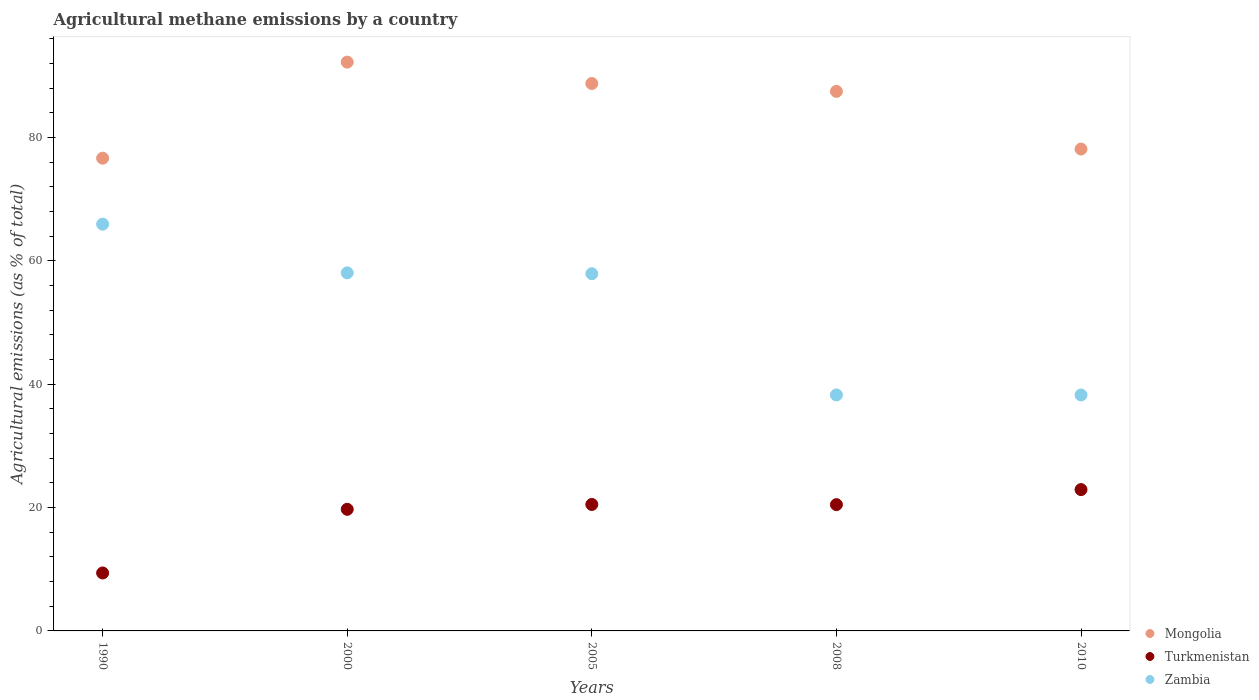Is the number of dotlines equal to the number of legend labels?
Your answer should be very brief. Yes. What is the amount of agricultural methane emitted in Mongolia in 2010?
Your answer should be very brief. 78.14. Across all years, what is the maximum amount of agricultural methane emitted in Zambia?
Your response must be concise. 65.96. Across all years, what is the minimum amount of agricultural methane emitted in Mongolia?
Provide a succinct answer. 76.66. In which year was the amount of agricultural methane emitted in Turkmenistan maximum?
Provide a succinct answer. 2010. What is the total amount of agricultural methane emitted in Turkmenistan in the graph?
Ensure brevity in your answer.  93.02. What is the difference between the amount of agricultural methane emitted in Zambia in 1990 and that in 2008?
Give a very brief answer. 27.69. What is the difference between the amount of agricultural methane emitted in Mongolia in 2000 and the amount of agricultural methane emitted in Zambia in 2010?
Offer a terse response. 53.98. What is the average amount of agricultural methane emitted in Mongolia per year?
Keep it short and to the point. 84.66. In the year 2008, what is the difference between the amount of agricultural methane emitted in Turkmenistan and amount of agricultural methane emitted in Mongolia?
Keep it short and to the point. -67.01. What is the ratio of the amount of agricultural methane emitted in Turkmenistan in 2000 to that in 2010?
Provide a short and direct response. 0.86. Is the amount of agricultural methane emitted in Mongolia in 2005 less than that in 2010?
Ensure brevity in your answer.  No. What is the difference between the highest and the second highest amount of agricultural methane emitted in Zambia?
Keep it short and to the point. 7.9. What is the difference between the highest and the lowest amount of agricultural methane emitted in Mongolia?
Keep it short and to the point. 15.58. In how many years, is the amount of agricultural methane emitted in Turkmenistan greater than the average amount of agricultural methane emitted in Turkmenistan taken over all years?
Your response must be concise. 4. Is the sum of the amount of agricultural methane emitted in Mongolia in 1990 and 2010 greater than the maximum amount of agricultural methane emitted in Zambia across all years?
Make the answer very short. Yes. Is the amount of agricultural methane emitted in Turkmenistan strictly greater than the amount of agricultural methane emitted in Mongolia over the years?
Provide a succinct answer. No. What is the difference between two consecutive major ticks on the Y-axis?
Ensure brevity in your answer.  20. Are the values on the major ticks of Y-axis written in scientific E-notation?
Your answer should be compact. No. Where does the legend appear in the graph?
Your response must be concise. Bottom right. What is the title of the graph?
Ensure brevity in your answer.  Agricultural methane emissions by a country. Does "Peru" appear as one of the legend labels in the graph?
Make the answer very short. No. What is the label or title of the X-axis?
Make the answer very short. Years. What is the label or title of the Y-axis?
Your response must be concise. Agricultural emissions (as % of total). What is the Agricultural emissions (as % of total) in Mongolia in 1990?
Keep it short and to the point. 76.66. What is the Agricultural emissions (as % of total) of Turkmenistan in 1990?
Ensure brevity in your answer.  9.4. What is the Agricultural emissions (as % of total) of Zambia in 1990?
Provide a short and direct response. 65.96. What is the Agricultural emissions (as % of total) of Mongolia in 2000?
Offer a very short reply. 92.24. What is the Agricultural emissions (as % of total) in Turkmenistan in 2000?
Your answer should be very brief. 19.72. What is the Agricultural emissions (as % of total) in Zambia in 2000?
Offer a very short reply. 58.06. What is the Agricultural emissions (as % of total) of Mongolia in 2005?
Ensure brevity in your answer.  88.77. What is the Agricultural emissions (as % of total) of Turkmenistan in 2005?
Make the answer very short. 20.51. What is the Agricultural emissions (as % of total) in Zambia in 2005?
Your answer should be compact. 57.92. What is the Agricultural emissions (as % of total) in Mongolia in 2008?
Give a very brief answer. 87.49. What is the Agricultural emissions (as % of total) in Turkmenistan in 2008?
Keep it short and to the point. 20.48. What is the Agricultural emissions (as % of total) of Zambia in 2008?
Your answer should be compact. 38.27. What is the Agricultural emissions (as % of total) in Mongolia in 2010?
Offer a very short reply. 78.14. What is the Agricultural emissions (as % of total) in Turkmenistan in 2010?
Your answer should be very brief. 22.92. What is the Agricultural emissions (as % of total) of Zambia in 2010?
Your response must be concise. 38.26. Across all years, what is the maximum Agricultural emissions (as % of total) in Mongolia?
Give a very brief answer. 92.24. Across all years, what is the maximum Agricultural emissions (as % of total) of Turkmenistan?
Your answer should be very brief. 22.92. Across all years, what is the maximum Agricultural emissions (as % of total) in Zambia?
Your answer should be very brief. 65.96. Across all years, what is the minimum Agricultural emissions (as % of total) of Mongolia?
Offer a terse response. 76.66. Across all years, what is the minimum Agricultural emissions (as % of total) in Turkmenistan?
Provide a short and direct response. 9.4. Across all years, what is the minimum Agricultural emissions (as % of total) of Zambia?
Give a very brief answer. 38.26. What is the total Agricultural emissions (as % of total) of Mongolia in the graph?
Offer a terse response. 423.3. What is the total Agricultural emissions (as % of total) in Turkmenistan in the graph?
Your answer should be compact. 93.02. What is the total Agricultural emissions (as % of total) of Zambia in the graph?
Provide a succinct answer. 258.47. What is the difference between the Agricultural emissions (as % of total) in Mongolia in 1990 and that in 2000?
Your answer should be very brief. -15.58. What is the difference between the Agricultural emissions (as % of total) in Turkmenistan in 1990 and that in 2000?
Make the answer very short. -10.32. What is the difference between the Agricultural emissions (as % of total) of Zambia in 1990 and that in 2000?
Your answer should be compact. 7.9. What is the difference between the Agricultural emissions (as % of total) of Mongolia in 1990 and that in 2005?
Keep it short and to the point. -12.11. What is the difference between the Agricultural emissions (as % of total) in Turkmenistan in 1990 and that in 2005?
Your answer should be very brief. -11.11. What is the difference between the Agricultural emissions (as % of total) of Zambia in 1990 and that in 2005?
Your response must be concise. 8.04. What is the difference between the Agricultural emissions (as % of total) in Mongolia in 1990 and that in 2008?
Your response must be concise. -10.83. What is the difference between the Agricultural emissions (as % of total) of Turkmenistan in 1990 and that in 2008?
Your response must be concise. -11.08. What is the difference between the Agricultural emissions (as % of total) of Zambia in 1990 and that in 2008?
Provide a short and direct response. 27.69. What is the difference between the Agricultural emissions (as % of total) in Mongolia in 1990 and that in 2010?
Your response must be concise. -1.48. What is the difference between the Agricultural emissions (as % of total) of Turkmenistan in 1990 and that in 2010?
Offer a very short reply. -13.52. What is the difference between the Agricultural emissions (as % of total) of Zambia in 1990 and that in 2010?
Provide a succinct answer. 27.7. What is the difference between the Agricultural emissions (as % of total) in Mongolia in 2000 and that in 2005?
Provide a short and direct response. 3.47. What is the difference between the Agricultural emissions (as % of total) in Turkmenistan in 2000 and that in 2005?
Make the answer very short. -0.79. What is the difference between the Agricultural emissions (as % of total) in Zambia in 2000 and that in 2005?
Offer a very short reply. 0.14. What is the difference between the Agricultural emissions (as % of total) in Mongolia in 2000 and that in 2008?
Ensure brevity in your answer.  4.74. What is the difference between the Agricultural emissions (as % of total) of Turkmenistan in 2000 and that in 2008?
Keep it short and to the point. -0.76. What is the difference between the Agricultural emissions (as % of total) in Zambia in 2000 and that in 2008?
Offer a very short reply. 19.79. What is the difference between the Agricultural emissions (as % of total) in Mongolia in 2000 and that in 2010?
Your answer should be very brief. 14.1. What is the difference between the Agricultural emissions (as % of total) in Turkmenistan in 2000 and that in 2010?
Keep it short and to the point. -3.2. What is the difference between the Agricultural emissions (as % of total) in Zambia in 2000 and that in 2010?
Your answer should be very brief. 19.8. What is the difference between the Agricultural emissions (as % of total) in Mongolia in 2005 and that in 2008?
Offer a very short reply. 1.28. What is the difference between the Agricultural emissions (as % of total) in Turkmenistan in 2005 and that in 2008?
Offer a very short reply. 0.03. What is the difference between the Agricultural emissions (as % of total) in Zambia in 2005 and that in 2008?
Your answer should be compact. 19.65. What is the difference between the Agricultural emissions (as % of total) in Mongolia in 2005 and that in 2010?
Make the answer very short. 10.63. What is the difference between the Agricultural emissions (as % of total) of Turkmenistan in 2005 and that in 2010?
Give a very brief answer. -2.41. What is the difference between the Agricultural emissions (as % of total) of Zambia in 2005 and that in 2010?
Your answer should be compact. 19.66. What is the difference between the Agricultural emissions (as % of total) of Mongolia in 2008 and that in 2010?
Make the answer very short. 9.35. What is the difference between the Agricultural emissions (as % of total) of Turkmenistan in 2008 and that in 2010?
Your answer should be compact. -2.44. What is the difference between the Agricultural emissions (as % of total) of Zambia in 2008 and that in 2010?
Give a very brief answer. 0.01. What is the difference between the Agricultural emissions (as % of total) of Mongolia in 1990 and the Agricultural emissions (as % of total) of Turkmenistan in 2000?
Ensure brevity in your answer.  56.94. What is the difference between the Agricultural emissions (as % of total) of Mongolia in 1990 and the Agricultural emissions (as % of total) of Zambia in 2000?
Give a very brief answer. 18.6. What is the difference between the Agricultural emissions (as % of total) of Turkmenistan in 1990 and the Agricultural emissions (as % of total) of Zambia in 2000?
Your answer should be very brief. -48.66. What is the difference between the Agricultural emissions (as % of total) of Mongolia in 1990 and the Agricultural emissions (as % of total) of Turkmenistan in 2005?
Give a very brief answer. 56.15. What is the difference between the Agricultural emissions (as % of total) of Mongolia in 1990 and the Agricultural emissions (as % of total) of Zambia in 2005?
Provide a short and direct response. 18.74. What is the difference between the Agricultural emissions (as % of total) of Turkmenistan in 1990 and the Agricultural emissions (as % of total) of Zambia in 2005?
Your answer should be compact. -48.52. What is the difference between the Agricultural emissions (as % of total) in Mongolia in 1990 and the Agricultural emissions (as % of total) in Turkmenistan in 2008?
Ensure brevity in your answer.  56.18. What is the difference between the Agricultural emissions (as % of total) of Mongolia in 1990 and the Agricultural emissions (as % of total) of Zambia in 2008?
Give a very brief answer. 38.39. What is the difference between the Agricultural emissions (as % of total) in Turkmenistan in 1990 and the Agricultural emissions (as % of total) in Zambia in 2008?
Your answer should be compact. -28.87. What is the difference between the Agricultural emissions (as % of total) in Mongolia in 1990 and the Agricultural emissions (as % of total) in Turkmenistan in 2010?
Your answer should be compact. 53.74. What is the difference between the Agricultural emissions (as % of total) in Mongolia in 1990 and the Agricultural emissions (as % of total) in Zambia in 2010?
Keep it short and to the point. 38.4. What is the difference between the Agricultural emissions (as % of total) in Turkmenistan in 1990 and the Agricultural emissions (as % of total) in Zambia in 2010?
Give a very brief answer. -28.86. What is the difference between the Agricultural emissions (as % of total) of Mongolia in 2000 and the Agricultural emissions (as % of total) of Turkmenistan in 2005?
Provide a succinct answer. 71.73. What is the difference between the Agricultural emissions (as % of total) of Mongolia in 2000 and the Agricultural emissions (as % of total) of Zambia in 2005?
Provide a short and direct response. 34.32. What is the difference between the Agricultural emissions (as % of total) of Turkmenistan in 2000 and the Agricultural emissions (as % of total) of Zambia in 2005?
Your answer should be compact. -38.2. What is the difference between the Agricultural emissions (as % of total) in Mongolia in 2000 and the Agricultural emissions (as % of total) in Turkmenistan in 2008?
Your response must be concise. 71.76. What is the difference between the Agricultural emissions (as % of total) of Mongolia in 2000 and the Agricultural emissions (as % of total) of Zambia in 2008?
Your response must be concise. 53.97. What is the difference between the Agricultural emissions (as % of total) of Turkmenistan in 2000 and the Agricultural emissions (as % of total) of Zambia in 2008?
Provide a short and direct response. -18.55. What is the difference between the Agricultural emissions (as % of total) of Mongolia in 2000 and the Agricultural emissions (as % of total) of Turkmenistan in 2010?
Your response must be concise. 69.32. What is the difference between the Agricultural emissions (as % of total) of Mongolia in 2000 and the Agricultural emissions (as % of total) of Zambia in 2010?
Make the answer very short. 53.98. What is the difference between the Agricultural emissions (as % of total) of Turkmenistan in 2000 and the Agricultural emissions (as % of total) of Zambia in 2010?
Ensure brevity in your answer.  -18.54. What is the difference between the Agricultural emissions (as % of total) in Mongolia in 2005 and the Agricultural emissions (as % of total) in Turkmenistan in 2008?
Your answer should be compact. 68.29. What is the difference between the Agricultural emissions (as % of total) of Mongolia in 2005 and the Agricultural emissions (as % of total) of Zambia in 2008?
Give a very brief answer. 50.5. What is the difference between the Agricultural emissions (as % of total) in Turkmenistan in 2005 and the Agricultural emissions (as % of total) in Zambia in 2008?
Keep it short and to the point. -17.76. What is the difference between the Agricultural emissions (as % of total) of Mongolia in 2005 and the Agricultural emissions (as % of total) of Turkmenistan in 2010?
Offer a very short reply. 65.85. What is the difference between the Agricultural emissions (as % of total) of Mongolia in 2005 and the Agricultural emissions (as % of total) of Zambia in 2010?
Ensure brevity in your answer.  50.51. What is the difference between the Agricultural emissions (as % of total) of Turkmenistan in 2005 and the Agricultural emissions (as % of total) of Zambia in 2010?
Provide a short and direct response. -17.75. What is the difference between the Agricultural emissions (as % of total) in Mongolia in 2008 and the Agricultural emissions (as % of total) in Turkmenistan in 2010?
Your answer should be very brief. 64.57. What is the difference between the Agricultural emissions (as % of total) of Mongolia in 2008 and the Agricultural emissions (as % of total) of Zambia in 2010?
Provide a succinct answer. 49.24. What is the difference between the Agricultural emissions (as % of total) of Turkmenistan in 2008 and the Agricultural emissions (as % of total) of Zambia in 2010?
Your answer should be very brief. -17.78. What is the average Agricultural emissions (as % of total) of Mongolia per year?
Your answer should be compact. 84.66. What is the average Agricultural emissions (as % of total) in Turkmenistan per year?
Keep it short and to the point. 18.6. What is the average Agricultural emissions (as % of total) of Zambia per year?
Give a very brief answer. 51.69. In the year 1990, what is the difference between the Agricultural emissions (as % of total) in Mongolia and Agricultural emissions (as % of total) in Turkmenistan?
Provide a short and direct response. 67.26. In the year 1990, what is the difference between the Agricultural emissions (as % of total) in Mongolia and Agricultural emissions (as % of total) in Zambia?
Your response must be concise. 10.7. In the year 1990, what is the difference between the Agricultural emissions (as % of total) of Turkmenistan and Agricultural emissions (as % of total) of Zambia?
Offer a very short reply. -56.56. In the year 2000, what is the difference between the Agricultural emissions (as % of total) of Mongolia and Agricultural emissions (as % of total) of Turkmenistan?
Your response must be concise. 72.52. In the year 2000, what is the difference between the Agricultural emissions (as % of total) of Mongolia and Agricultural emissions (as % of total) of Zambia?
Your response must be concise. 34.18. In the year 2000, what is the difference between the Agricultural emissions (as % of total) of Turkmenistan and Agricultural emissions (as % of total) of Zambia?
Your answer should be compact. -38.34. In the year 2005, what is the difference between the Agricultural emissions (as % of total) in Mongolia and Agricultural emissions (as % of total) in Turkmenistan?
Your answer should be very brief. 68.26. In the year 2005, what is the difference between the Agricultural emissions (as % of total) of Mongolia and Agricultural emissions (as % of total) of Zambia?
Your answer should be compact. 30.85. In the year 2005, what is the difference between the Agricultural emissions (as % of total) in Turkmenistan and Agricultural emissions (as % of total) in Zambia?
Make the answer very short. -37.41. In the year 2008, what is the difference between the Agricultural emissions (as % of total) of Mongolia and Agricultural emissions (as % of total) of Turkmenistan?
Your response must be concise. 67.01. In the year 2008, what is the difference between the Agricultural emissions (as % of total) in Mongolia and Agricultural emissions (as % of total) in Zambia?
Offer a very short reply. 49.22. In the year 2008, what is the difference between the Agricultural emissions (as % of total) of Turkmenistan and Agricultural emissions (as % of total) of Zambia?
Your response must be concise. -17.79. In the year 2010, what is the difference between the Agricultural emissions (as % of total) in Mongolia and Agricultural emissions (as % of total) in Turkmenistan?
Ensure brevity in your answer.  55.22. In the year 2010, what is the difference between the Agricultural emissions (as % of total) of Mongolia and Agricultural emissions (as % of total) of Zambia?
Your answer should be very brief. 39.88. In the year 2010, what is the difference between the Agricultural emissions (as % of total) of Turkmenistan and Agricultural emissions (as % of total) of Zambia?
Make the answer very short. -15.34. What is the ratio of the Agricultural emissions (as % of total) of Mongolia in 1990 to that in 2000?
Offer a terse response. 0.83. What is the ratio of the Agricultural emissions (as % of total) of Turkmenistan in 1990 to that in 2000?
Your response must be concise. 0.48. What is the ratio of the Agricultural emissions (as % of total) in Zambia in 1990 to that in 2000?
Your answer should be compact. 1.14. What is the ratio of the Agricultural emissions (as % of total) in Mongolia in 1990 to that in 2005?
Offer a terse response. 0.86. What is the ratio of the Agricultural emissions (as % of total) in Turkmenistan in 1990 to that in 2005?
Offer a very short reply. 0.46. What is the ratio of the Agricultural emissions (as % of total) in Zambia in 1990 to that in 2005?
Your answer should be very brief. 1.14. What is the ratio of the Agricultural emissions (as % of total) in Mongolia in 1990 to that in 2008?
Your answer should be very brief. 0.88. What is the ratio of the Agricultural emissions (as % of total) of Turkmenistan in 1990 to that in 2008?
Give a very brief answer. 0.46. What is the ratio of the Agricultural emissions (as % of total) in Zambia in 1990 to that in 2008?
Give a very brief answer. 1.72. What is the ratio of the Agricultural emissions (as % of total) in Mongolia in 1990 to that in 2010?
Ensure brevity in your answer.  0.98. What is the ratio of the Agricultural emissions (as % of total) of Turkmenistan in 1990 to that in 2010?
Provide a short and direct response. 0.41. What is the ratio of the Agricultural emissions (as % of total) of Zambia in 1990 to that in 2010?
Provide a short and direct response. 1.72. What is the ratio of the Agricultural emissions (as % of total) in Mongolia in 2000 to that in 2005?
Keep it short and to the point. 1.04. What is the ratio of the Agricultural emissions (as % of total) of Turkmenistan in 2000 to that in 2005?
Your response must be concise. 0.96. What is the ratio of the Agricultural emissions (as % of total) of Zambia in 2000 to that in 2005?
Your response must be concise. 1. What is the ratio of the Agricultural emissions (as % of total) of Mongolia in 2000 to that in 2008?
Ensure brevity in your answer.  1.05. What is the ratio of the Agricultural emissions (as % of total) of Turkmenistan in 2000 to that in 2008?
Your response must be concise. 0.96. What is the ratio of the Agricultural emissions (as % of total) of Zambia in 2000 to that in 2008?
Your answer should be compact. 1.52. What is the ratio of the Agricultural emissions (as % of total) of Mongolia in 2000 to that in 2010?
Keep it short and to the point. 1.18. What is the ratio of the Agricultural emissions (as % of total) in Turkmenistan in 2000 to that in 2010?
Your answer should be compact. 0.86. What is the ratio of the Agricultural emissions (as % of total) of Zambia in 2000 to that in 2010?
Your response must be concise. 1.52. What is the ratio of the Agricultural emissions (as % of total) in Mongolia in 2005 to that in 2008?
Keep it short and to the point. 1.01. What is the ratio of the Agricultural emissions (as % of total) in Turkmenistan in 2005 to that in 2008?
Offer a terse response. 1. What is the ratio of the Agricultural emissions (as % of total) in Zambia in 2005 to that in 2008?
Make the answer very short. 1.51. What is the ratio of the Agricultural emissions (as % of total) of Mongolia in 2005 to that in 2010?
Offer a terse response. 1.14. What is the ratio of the Agricultural emissions (as % of total) of Turkmenistan in 2005 to that in 2010?
Offer a very short reply. 0.89. What is the ratio of the Agricultural emissions (as % of total) in Zambia in 2005 to that in 2010?
Ensure brevity in your answer.  1.51. What is the ratio of the Agricultural emissions (as % of total) of Mongolia in 2008 to that in 2010?
Give a very brief answer. 1.12. What is the ratio of the Agricultural emissions (as % of total) of Turkmenistan in 2008 to that in 2010?
Your answer should be compact. 0.89. What is the ratio of the Agricultural emissions (as % of total) of Zambia in 2008 to that in 2010?
Offer a terse response. 1. What is the difference between the highest and the second highest Agricultural emissions (as % of total) of Mongolia?
Keep it short and to the point. 3.47. What is the difference between the highest and the second highest Agricultural emissions (as % of total) in Turkmenistan?
Your response must be concise. 2.41. What is the difference between the highest and the second highest Agricultural emissions (as % of total) in Zambia?
Offer a terse response. 7.9. What is the difference between the highest and the lowest Agricultural emissions (as % of total) in Mongolia?
Provide a succinct answer. 15.58. What is the difference between the highest and the lowest Agricultural emissions (as % of total) in Turkmenistan?
Offer a very short reply. 13.52. What is the difference between the highest and the lowest Agricultural emissions (as % of total) in Zambia?
Offer a very short reply. 27.7. 